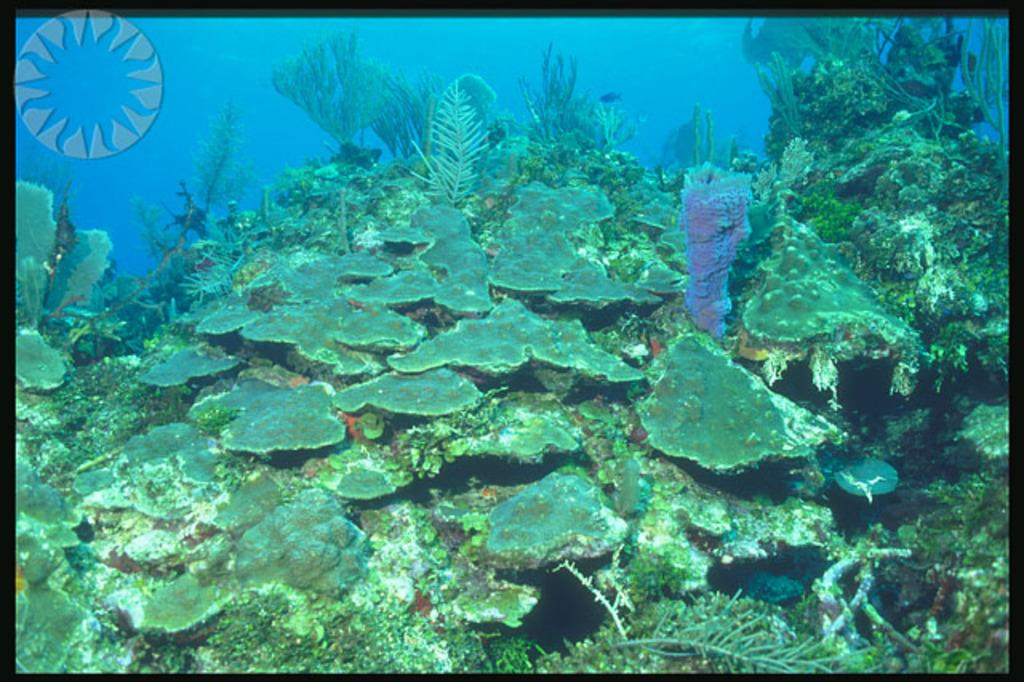What type of environment is depicted in the image? The image shows plants in the water. Can you describe the plants in the image? The plants are submerged in the water. What might be the purpose of having plants in the water? The plants may help to purify the water or provide a habitat for aquatic life. What is the effect of the sea on the plants in the image? There is no sea present in the image; it only shows plants in the water. 